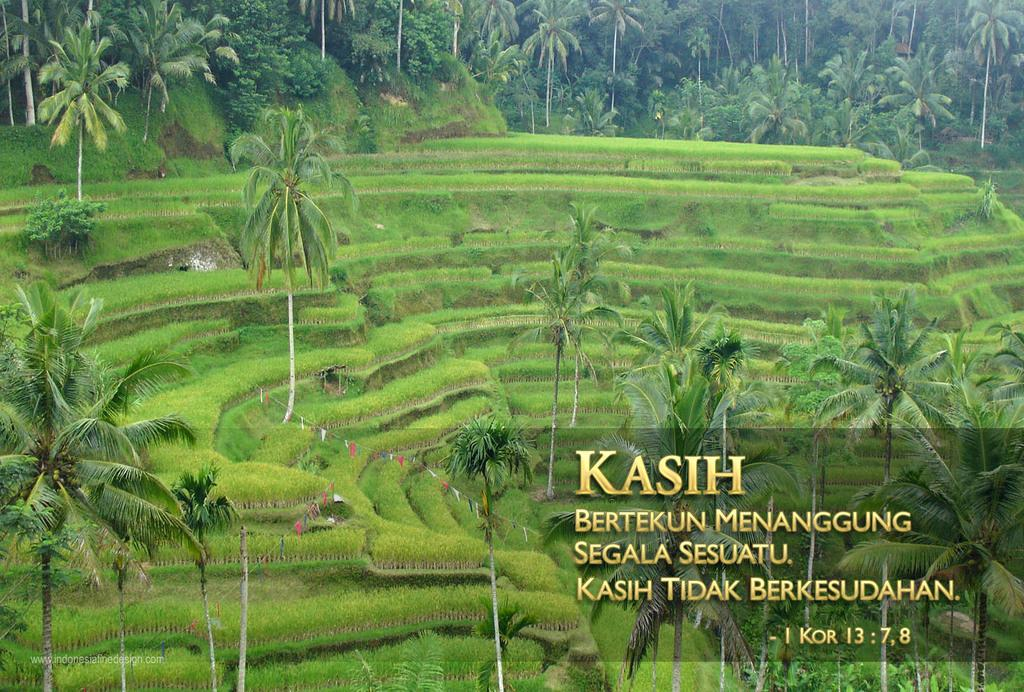What type of vegetation can be seen in the image? There are trees and grass in the image. Can you describe the natural environment depicted in the image? The image features trees and grass, which suggests a natural setting. What type of rifle is the laborer carrying in the image? There is no laborer or rifle present in the image; it only features trees and grass. 